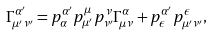<formula> <loc_0><loc_0><loc_500><loc_500>\Gamma ^ { \alpha ^ { \prime } } _ { \mu ^ { \prime } \nu ^ { \prime } } = p ^ { \alpha ^ { \prime } } _ { \alpha } p ^ { \mu } _ { \mu ^ { \prime } } p ^ { \nu } _ { \nu ^ { \prime } } \Gamma ^ { \alpha } _ { \mu \nu } + p ^ { \alpha ^ { \prime } } _ { \epsilon } p ^ { \epsilon } _ { \mu ^ { \prime } \nu ^ { \prime } } ,</formula> 